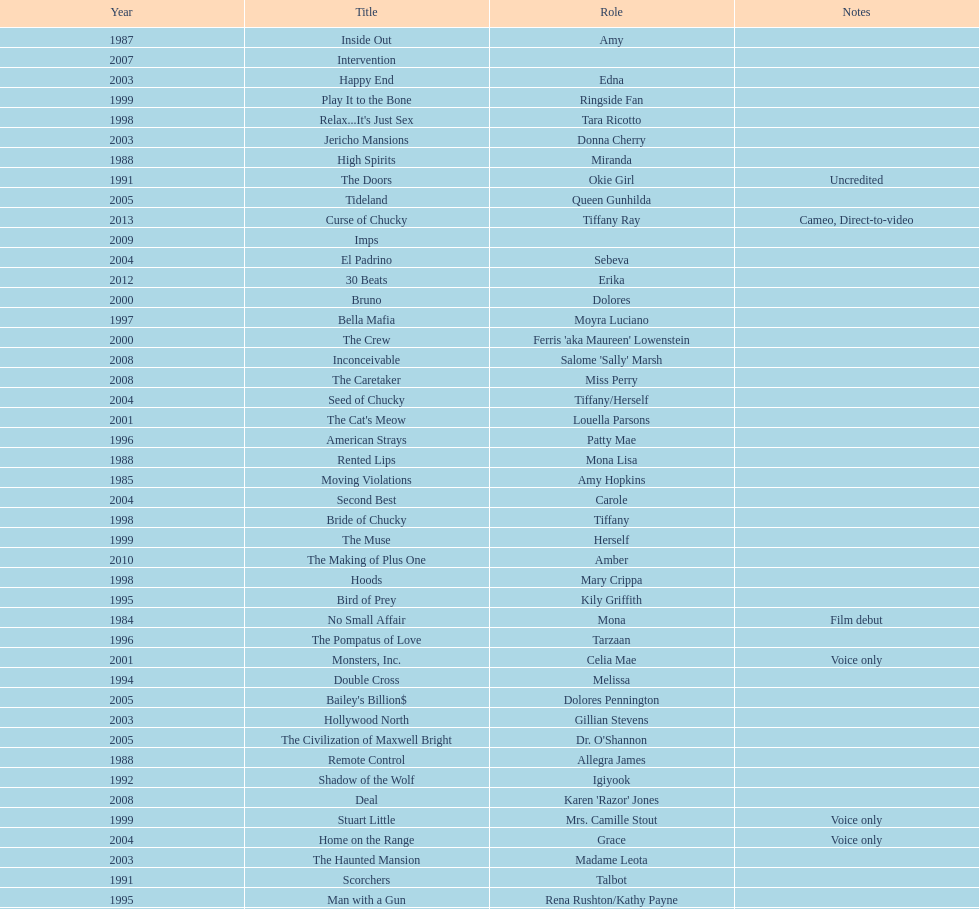How many rolls did jennifer tilly play in the 1980s? 11. 